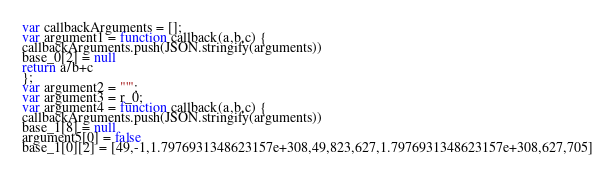<code> <loc_0><loc_0><loc_500><loc_500><_JavaScript_>





var callbackArguments = [];
var argument1 = function callback(a,b,c) { 
callbackArguments.push(JSON.stringify(arguments))
base_0[2] = null
return a/b+c
};
var argument2 = "'";
var argument3 = r_0;
var argument4 = function callback(a,b,c) { 
callbackArguments.push(JSON.stringify(arguments))
base_1[8] = null
argument5[0] = false
base_1[0][2] = [49,-1,1.7976931348623157e+308,49,823,627,1.7976931348623157e+308,627,705]</code> 